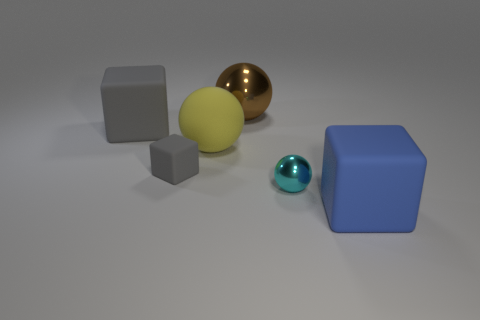Add 3 brown shiny objects. How many objects exist? 9 Subtract all big blue blocks. How many blocks are left? 2 Add 2 cyan blocks. How many cyan blocks exist? 2 Subtract all yellow spheres. How many spheres are left? 2 Subtract 0 cyan blocks. How many objects are left? 6 Subtract all brown cubes. Subtract all blue cylinders. How many cubes are left? 3 Subtract all brown cylinders. How many brown balls are left? 1 Subtract all big yellow matte spheres. Subtract all blue matte objects. How many objects are left? 4 Add 5 large gray rubber blocks. How many large gray rubber blocks are left? 6 